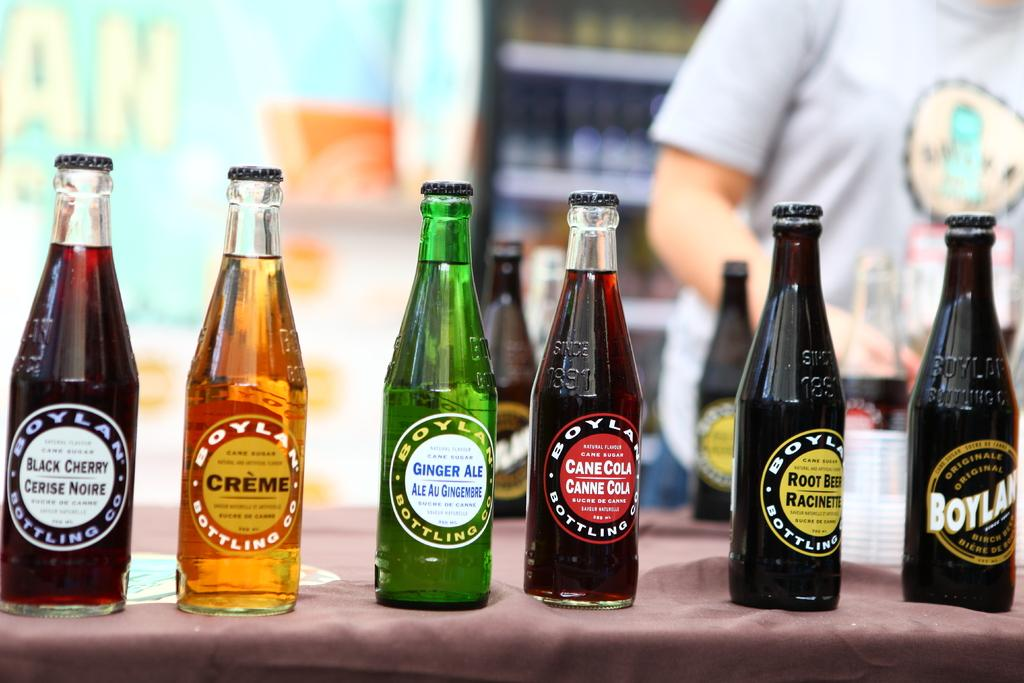<image>
Render a clear and concise summary of the photo. Various bottles of soda such as ginger ale and black cherry 